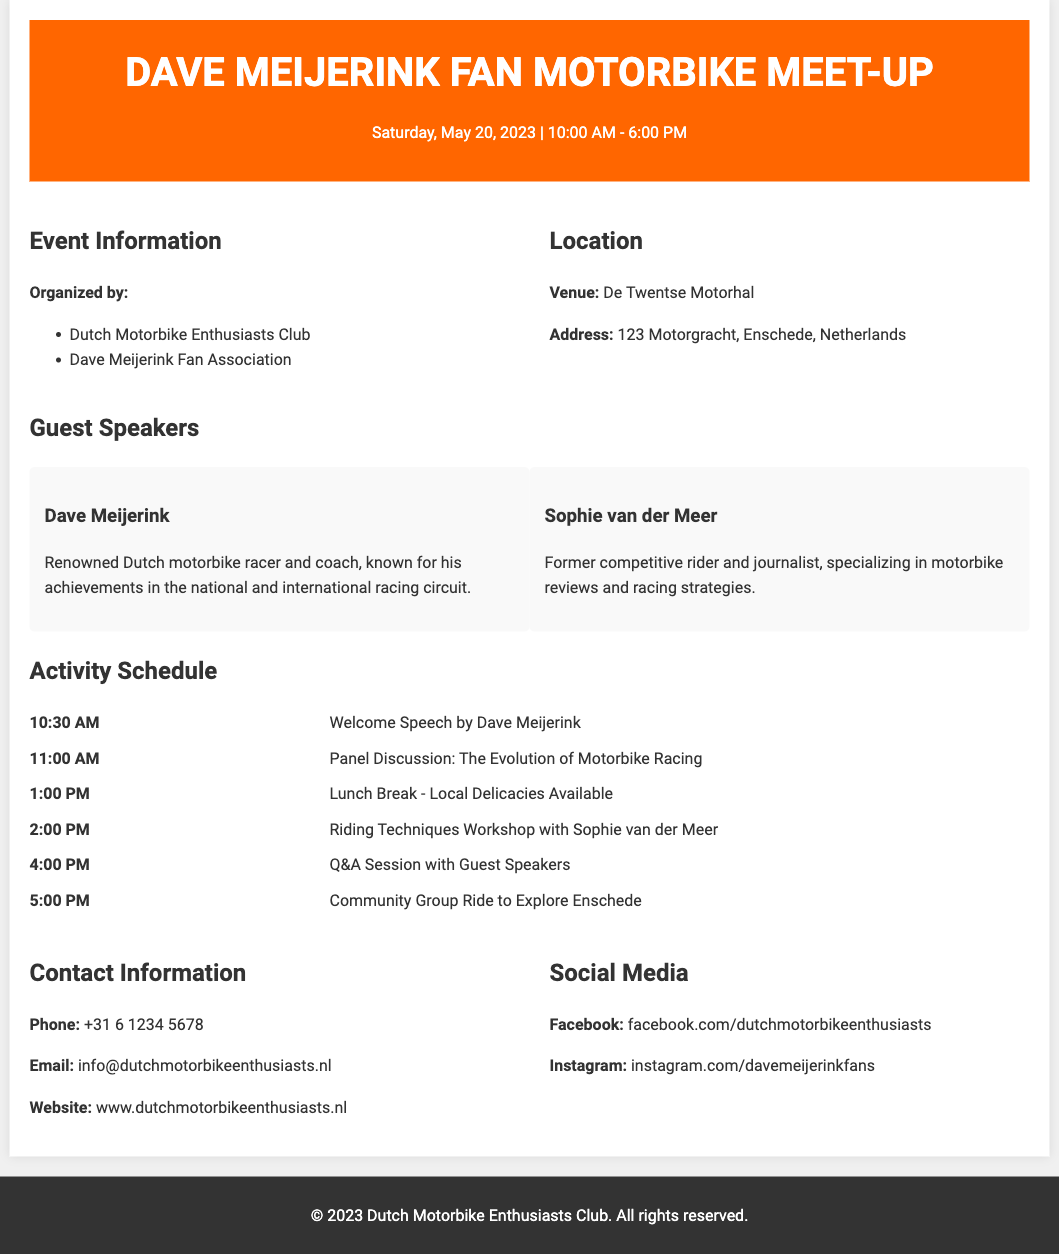what is the name of the venue? The venue for the event is mentioned in the document as "De Twentse Motorhal."
Answer: De Twentse Motorhal who is the renowned guest speaker? The document lists Dave Meijerink as a renowned guest speaker at the event.
Answer: Dave Meijerink what time does the event start? The document states that the event begins at 10:00 AM on May 20, 2023.
Answer: 10:00 AM what is the date of the meet-up? The meet-up is scheduled for Saturday, May 20, 2023, as indicated in the document.
Answer: May 20, 2023 who will conduct the riding techniques workshop? The document specifies that Sophie van der Meer will lead the riding techniques workshop.
Answer: Sophie van der Meer how long is the lunch break scheduled for? The lunch break is scheduled at 1:00 PM, but the document does not specify its duration. This hints at a typical duration of about an hour.
Answer: 1 hour where can attendees find local delicacies? The document states that local delicacies will be available during the lunch break.
Answer: Lunch Break what time does the community ride start? The document indicates that the community group ride starts at 5:00 PM.
Answer: 5:00 PM what is the website provided for the event? The website where attendees can find more information about the event is given in the document as "www.dutchmotorbikeenthusiasts.nl."
Answer: www.dutchmotorbikeenthusiasts.nl 